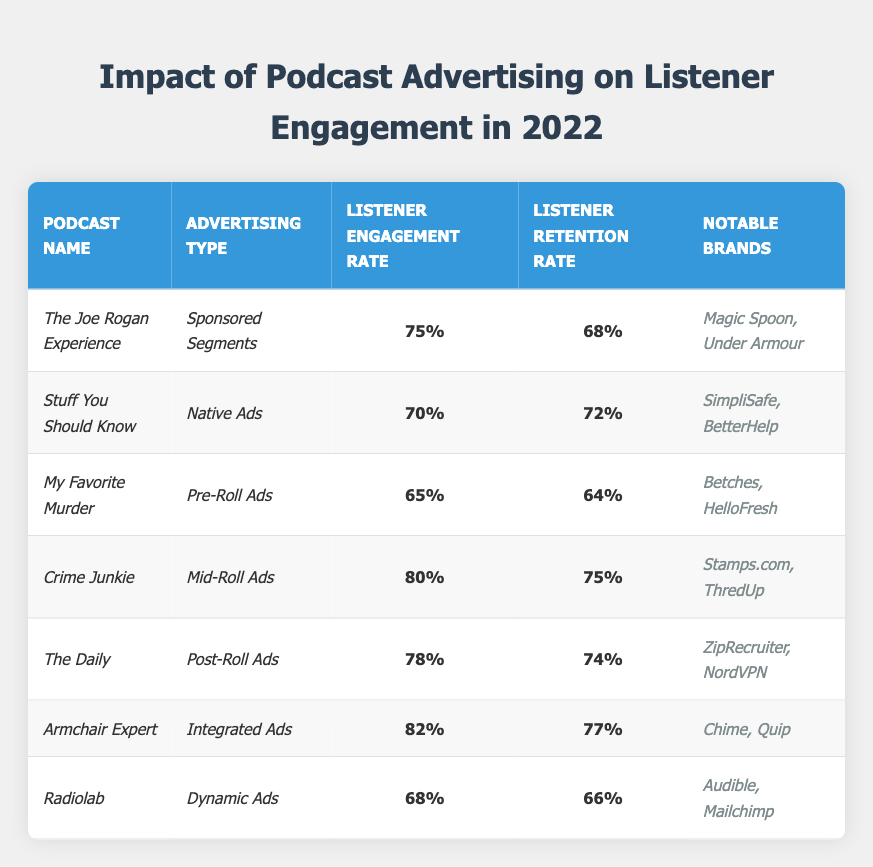What is the listener engagement rate of _Crime Junkie_? The table lists _Crime Junkie_'s listener engagement rate as 80% in the "Listener Engagement Rate" column.
Answer: 80% Which podcast has the highest listener retention rate? By comparing the listener retention rates in the table, _Armchair Expert_ has the highest rate at 77%.
Answer: _Armchair Expert_ What advertising type was used for _The Daily_? In the "Advertising Type" column for _The Daily_, it states "Post-Roll Ads."
Answer: Post-Roll Ads What is the average listener engagement rate of the podcasts using _Native Ads_? The only podcast listed with _Native Ads_ is _Stuff You Should Know_, which has a listener engagement rate of 70%. As there's only one data point, the average is 70%.
Answer: 70% Is it true that _My Favorite Murder_ has a lower listener engagement rate than _Radiolab_? _My Favorite Murder_ has an engagement rate of 65% while _Radiolab_ has 68%. Since 65% is less than 68%, the statement is true.
Answer: True Which notable brands are associated with _Armchair Expert_? The "Notable Brands" column for _Armchair Expert_ lists "Chime, Quip."
Answer: Chime, Quip Calculate the difference in listener retention rates between _Crime Junkie_ and _My Favorite Murder_. _Crime Junkie_ has a retention rate of 75% and _My Favorite Murder_ has 64%. The difference is 75% - 64% = 11%.
Answer: 11% How many podcasts displayed a listener engagement rate above 75%? The podcasts with engagement rates above 75% are _Crime Junkie_ (80%), _The Daily_ (78%), and _Armchair Expert_ (82%). That accounts for 3 podcasts.
Answer: 3 Which podcast has the least listener retention rate and what is that rate? _My Favorite Murder_ has the least listener retention rate at 64%, which can be found in the corresponding column.
Answer: 64% Compare the listener engagement rates of _The Joe Rogan Experience_ and _The Daily_. Which one is higher? _The Joe Rogan Experience_ has a listener engagement rate of 75%, while _The Daily_ has 78%. Since 78% is higher, _The Daily_ has a higher engagement rate.
Answer: _The Daily_ 